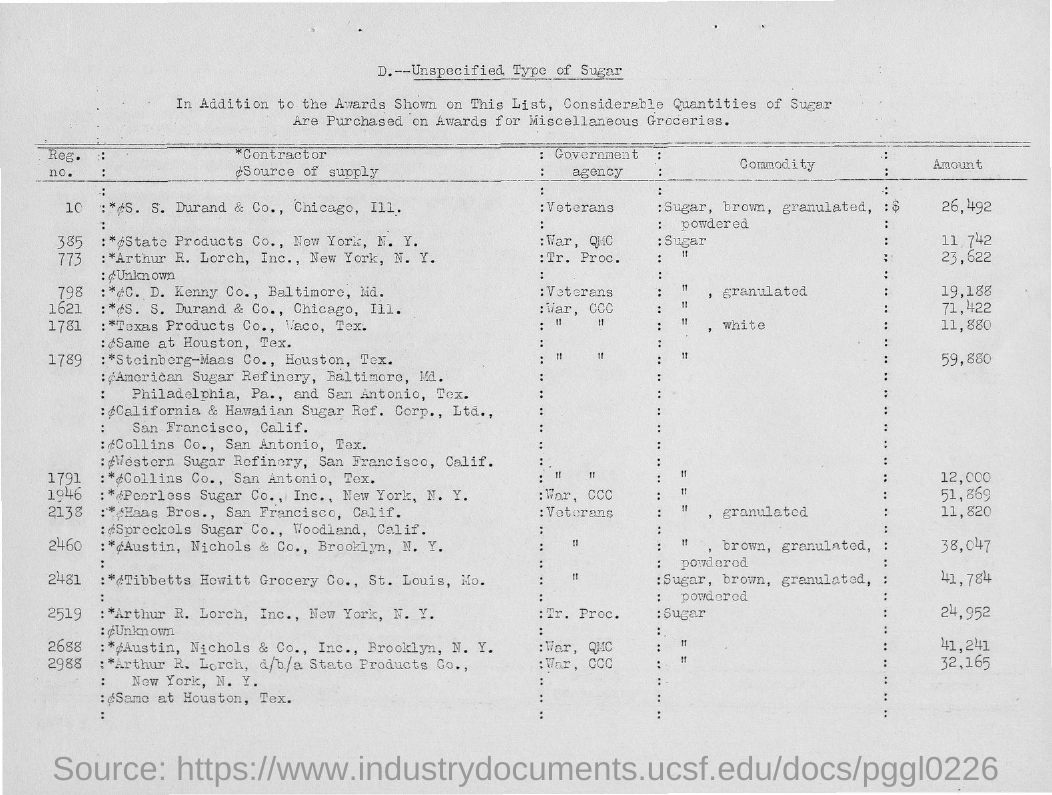What is the amount for the reg.no. 10?
Your answer should be compact. 26,492. 